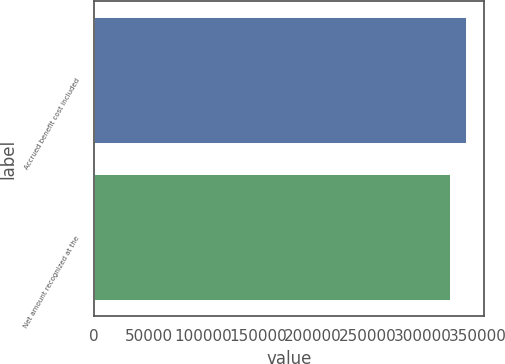<chart> <loc_0><loc_0><loc_500><loc_500><bar_chart><fcel>Accrued benefit cost included<fcel>Net amount recognized at the<nl><fcel>339045<fcel>324852<nl></chart> 